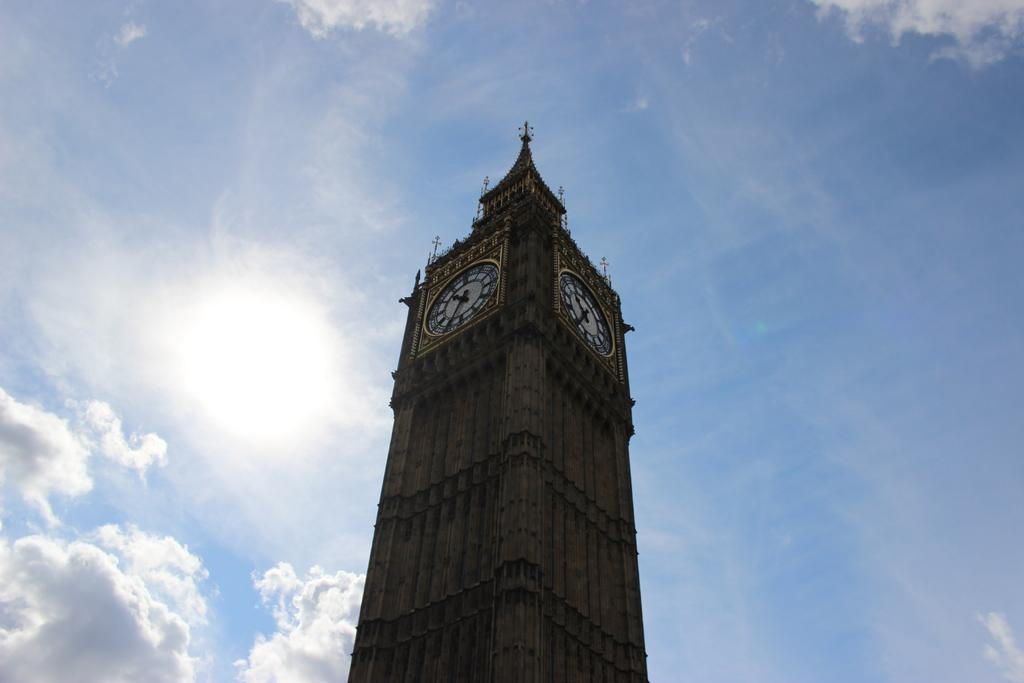Please provide a concise description of this image. In this picture we can see a tower with clocks on it and in the background we can see sky with clouds. 